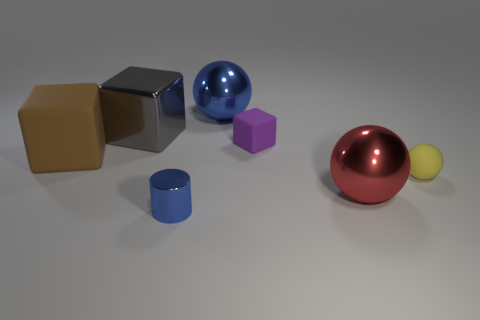Is the small blue cylinder made of the same material as the blue ball?
Ensure brevity in your answer.  Yes. How many other big brown rubber things have the same shape as the brown rubber object?
Offer a very short reply. 0. There is a brown thing that is the same material as the tiny yellow ball; what shape is it?
Offer a terse response. Cube. What is the color of the tiny thing on the left side of the sphere that is left of the large red shiny object?
Ensure brevity in your answer.  Blue. Do the tiny shiny thing and the small matte block have the same color?
Make the answer very short. No. What material is the sphere to the left of the tiny thing that is behind the small yellow ball?
Provide a succinct answer. Metal. There is a purple thing that is the same shape as the gray metal thing; what is its material?
Keep it short and to the point. Rubber. Is there a brown matte thing on the right side of the blue object that is behind the small object in front of the yellow object?
Ensure brevity in your answer.  No. What number of other things are there of the same color as the small sphere?
Your answer should be very brief. 0. What number of things are to the right of the purple matte object and in front of the red metal ball?
Provide a short and direct response. 0. 